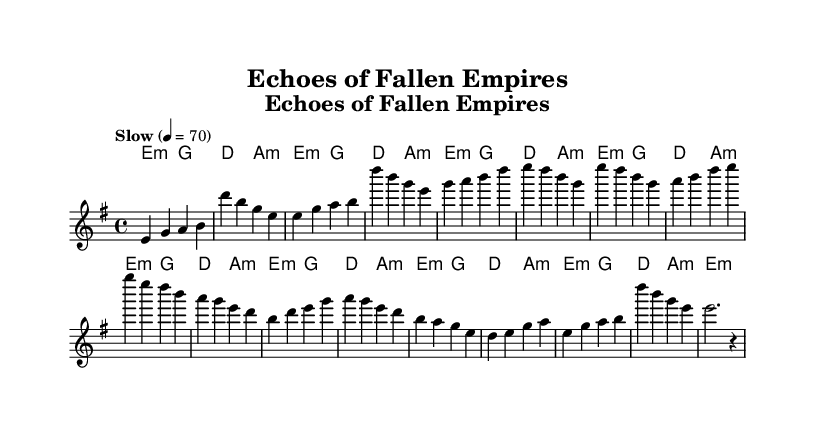What is the key signature of this music? The key signature is E minor, which contains one sharp (F#). This can be identified in the beginning of the sheet music.
Answer: E minor What is the time signature of this music? The time signature is 4/4, indicated at the start of the sheet music. This means there are four beats in each measure.
Answer: 4/4 What is the tempo marking given in the score? The tempo marking is "Slow" and the tempo is set at 4 = 70, meaning that there should be 70 beats per minute in this song.
Answer: Slow, 4 = 70 How many measures are in the melody section? The melody section contains 16 measures, which can be counted from the beginning of the melody notation to the end.
Answer: 16 What is the first note of the melody? The first note of the melody is E, which is indicated at the start of the melody line.
Answer: E What type of chord progression is primarily used in this piece? The chord progression follows a minor pattern, primarily using E minor and its related chords (g, a minor, d) as seen throughout the harmonies section.
Answer: Minor progression What is the main theme reflected in the lyrics of this blues piece? The main theme reflects on the fall of empires and the ruins they left behind, which is a traditional subject matter in blues music.
Answer: Fall of empires 